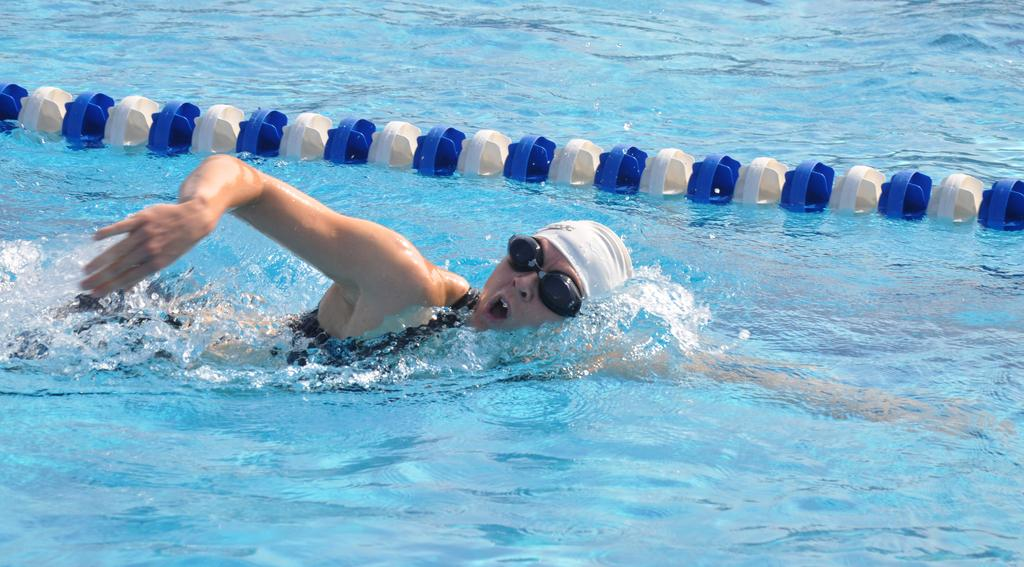What is the person in the image doing? The person is swimming in the water. What can be seen beside the person while they are swimming? Lane lines are present beside the person. What type of reward is the person receiving for their performance in the image? There is no reward present in the image, as the person is simply swimming in the water. Can you see any horses in the image? No, there are no horses present in the image. 